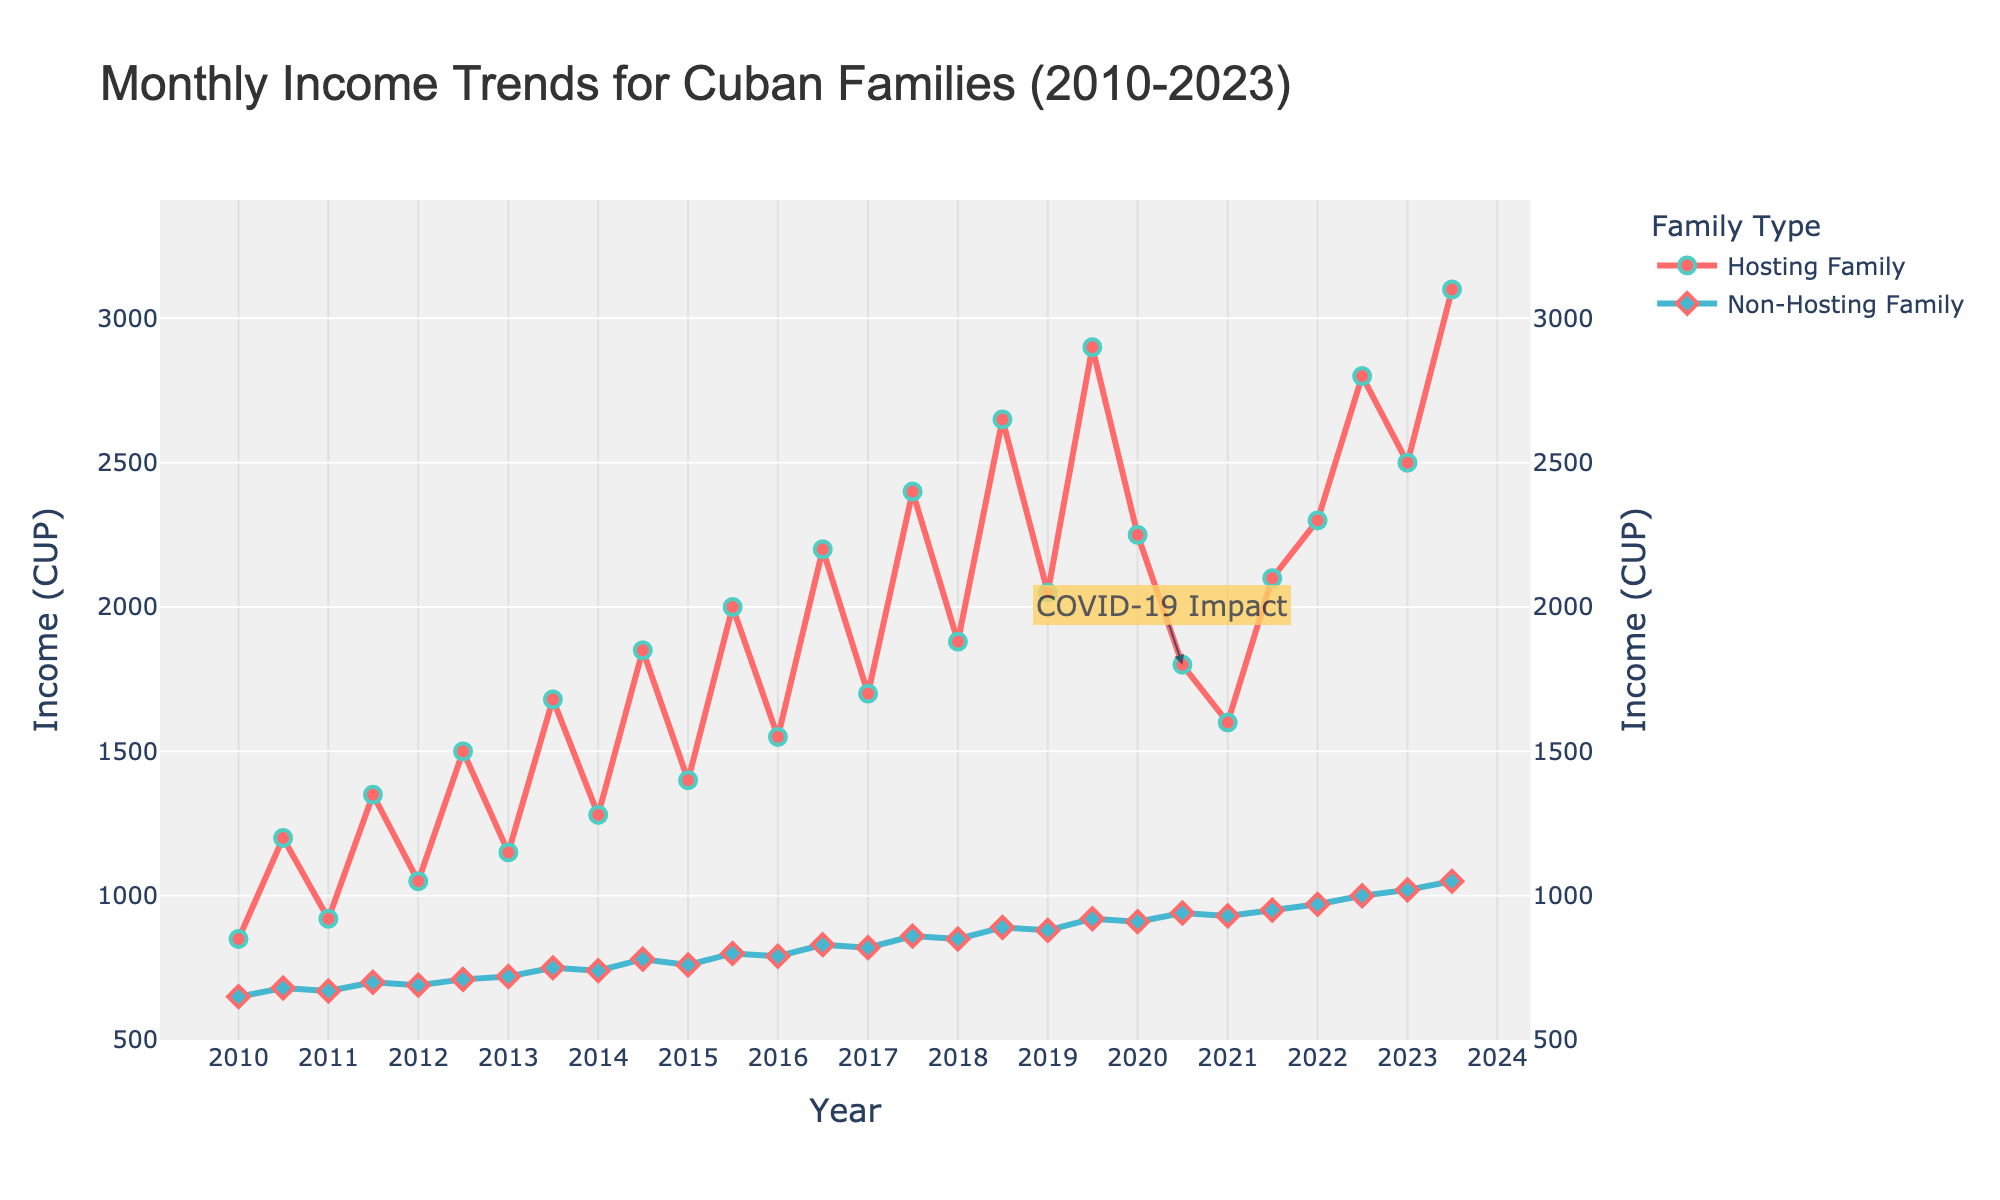What is the maximum income of hosting families after 2020? To find the answer, look at the line representing hosting family income from 2020 onward and identify the highest point. In 2023, July, the hosting family income reaches 3100 CUP.
Answer: 3100 CUP Compare the income changes of hosting and non-hosting families from 2020 July to 2021 January. Hosting family income drops from 1800 CUP to 1600 CUP, a decrease of 200 CUP. Non-hosting family income decreases from 940 CUP to 930 CUP, a decrease of 10 CUP.
Answer: Hosting families decrease by 200 CUP, non-hosting families decrease by 10 CUP Which family type had a higher income in January 2017, and by how much? On the figure, find the January 2017 data points for both family types. Hosting families had 1700 CUP, while non-hosting families had 820 CUP. The difference is 1700 - 820 = 880 CUP.
Answer: Hosting families by 880 CUP What is the difference in income between hosting and non-hosting families in July 2023? Look for the data points in July 2023 for both family types. Hosting families had 3100 CUP, and non-hosting families had 1050 CUP. The difference is 3100 - 1050 = 2050 CUP.
Answer: 2050 CUP How did the income of hosting families change from July 2020 to July 2022? Identify the data points for these months for hosting families. In July 2020, the income was 1800 CUP. In July 2022, the income was 2800 CUP. The change is 2800 - 1800 = 1000 CUP.
Answer: Increased by 1000 CUP What is the average income of non-hosting families in July from 2019 to 2023? Note down the incomes in July for non-hosting families: 920 (2019), 940 (2020), 950 (2021), 1000 (2022), and 1050 (2023). The average is (920 + 940 + 950 + 1000 + 1050) / 5 = 968 CUP.
Answer: 968 CUP In which year did hosting families see their income cross 2000 CUP for the first time? Follow the line representing hosting family income and find the first year when it crosses the 2000 CUP mark. This happens in July 2015.
Answer: 2015 Between January 2011 and January 2013, which family type saw a greater percentage increase in income? Calculate the percentage increase for both types over this period. Hosting families: (1150 - 920) / 920 * 100 = 25%. Non-hosting families: (720 - 670) / 670 * 100 = 7.46%.
Answer: Hosting families What event might explain the drop in hosting family income in July 2020? There is an annotation marking "COVID-19 Impact" next to the July 2020 data point, indicating the pandemic’s impact on hosting families' income.
Answer: COVID-19 Pandemic Which family type had a steadier income trend between 2010 and 2023? Observe the trend lines for both types. Non-hosting families have a more gradual and consistent increase, while hosting families show greater fluctuations.
Answer: Non-hosting families 